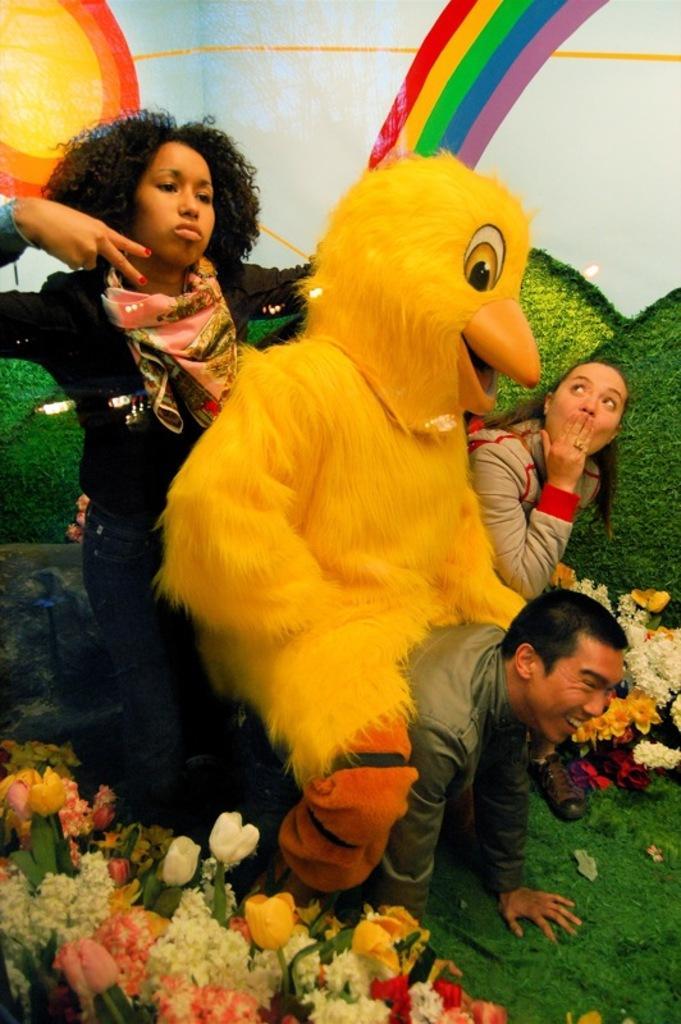Please provide a concise description of this image. This image consists of four persons. In the front, two persons are sitting on a man. And we can see a person wearing a costume. At the bottom, there are flowers and grass. In the background, it looks like a wall. 